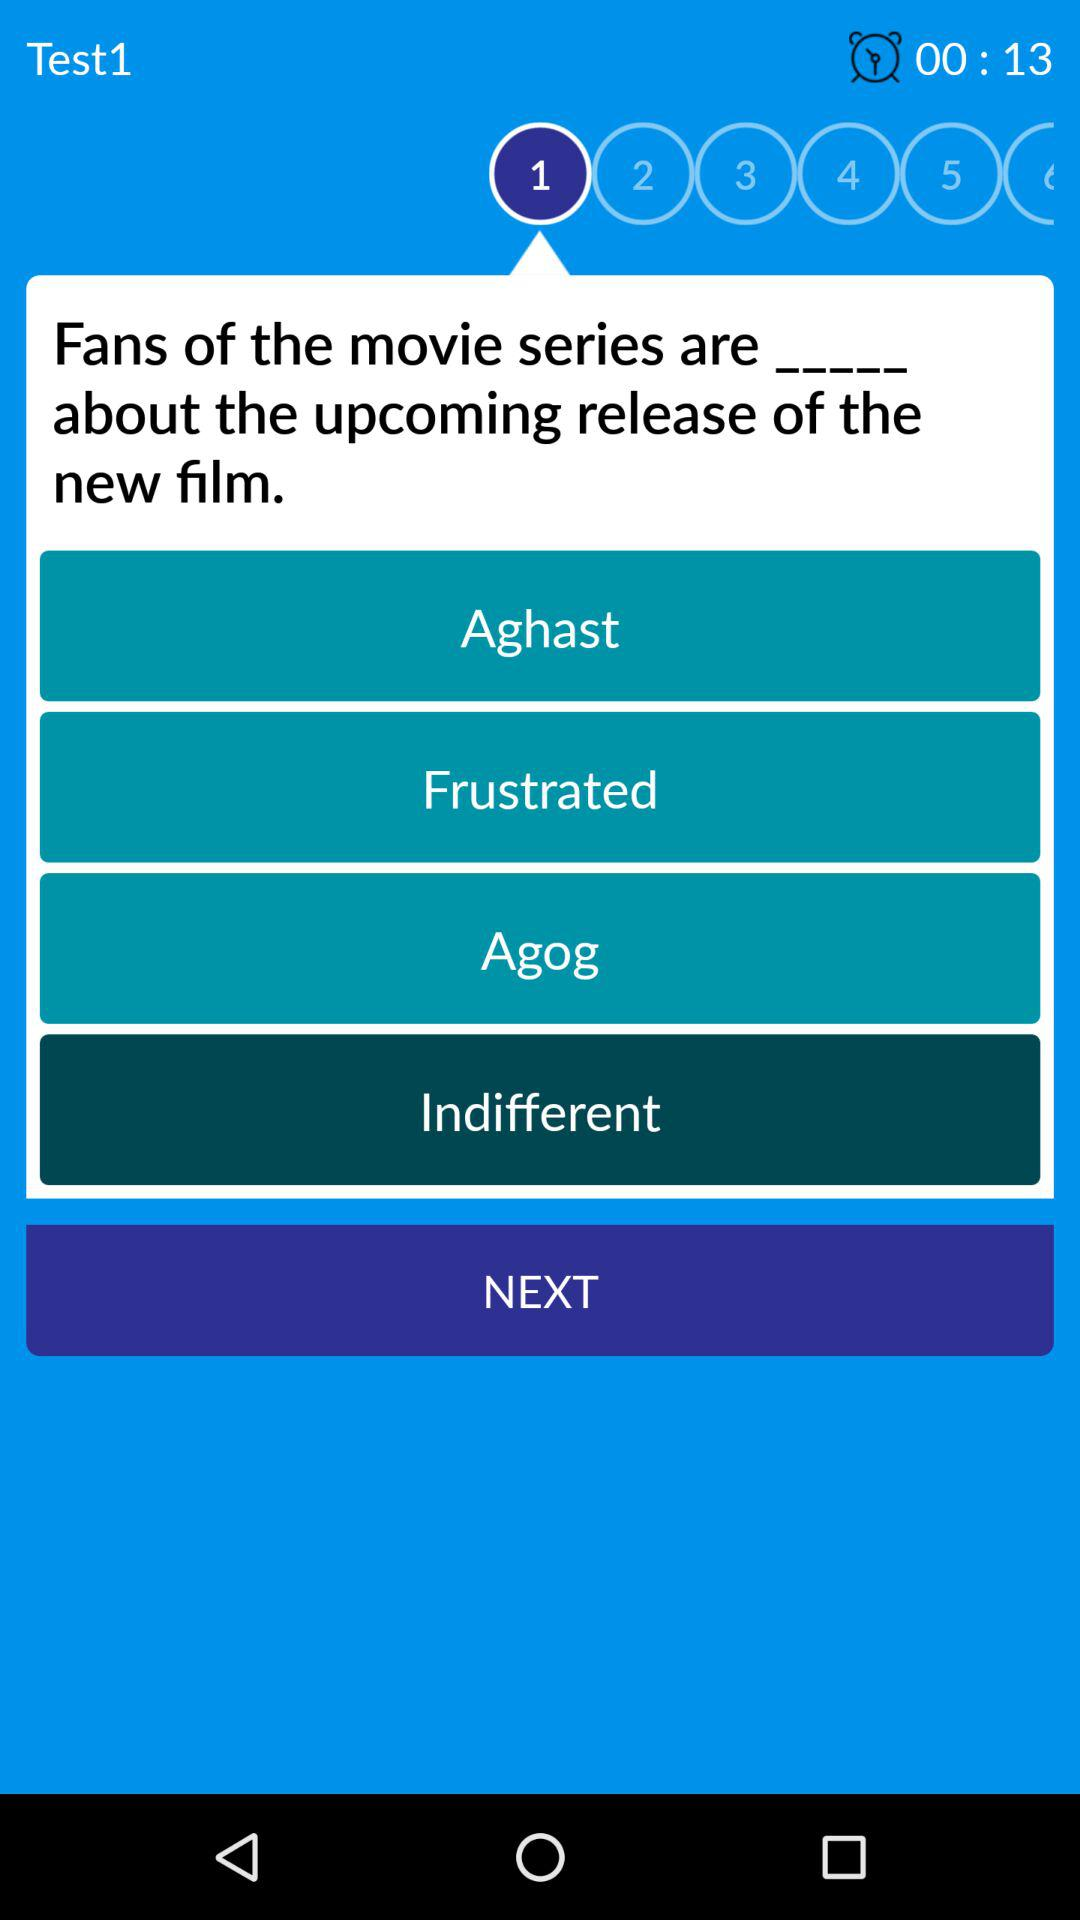What is the current question number? The current question number is 1. 